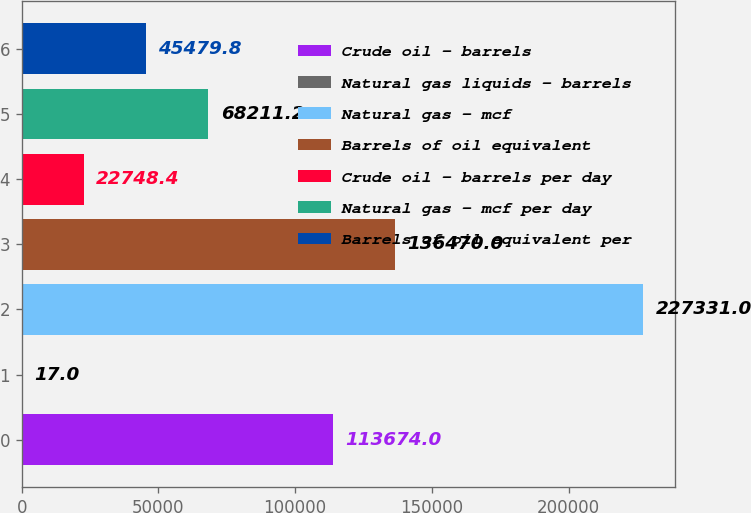Convert chart to OTSL. <chart><loc_0><loc_0><loc_500><loc_500><bar_chart><fcel>Crude oil - barrels<fcel>Natural gas liquids - barrels<fcel>Natural gas - mcf<fcel>Barrels of oil equivalent<fcel>Crude oil - barrels per day<fcel>Natural gas - mcf per day<fcel>Barrels of oil equivalent per<nl><fcel>113674<fcel>17<fcel>227331<fcel>136470<fcel>22748.4<fcel>68211.2<fcel>45479.8<nl></chart> 